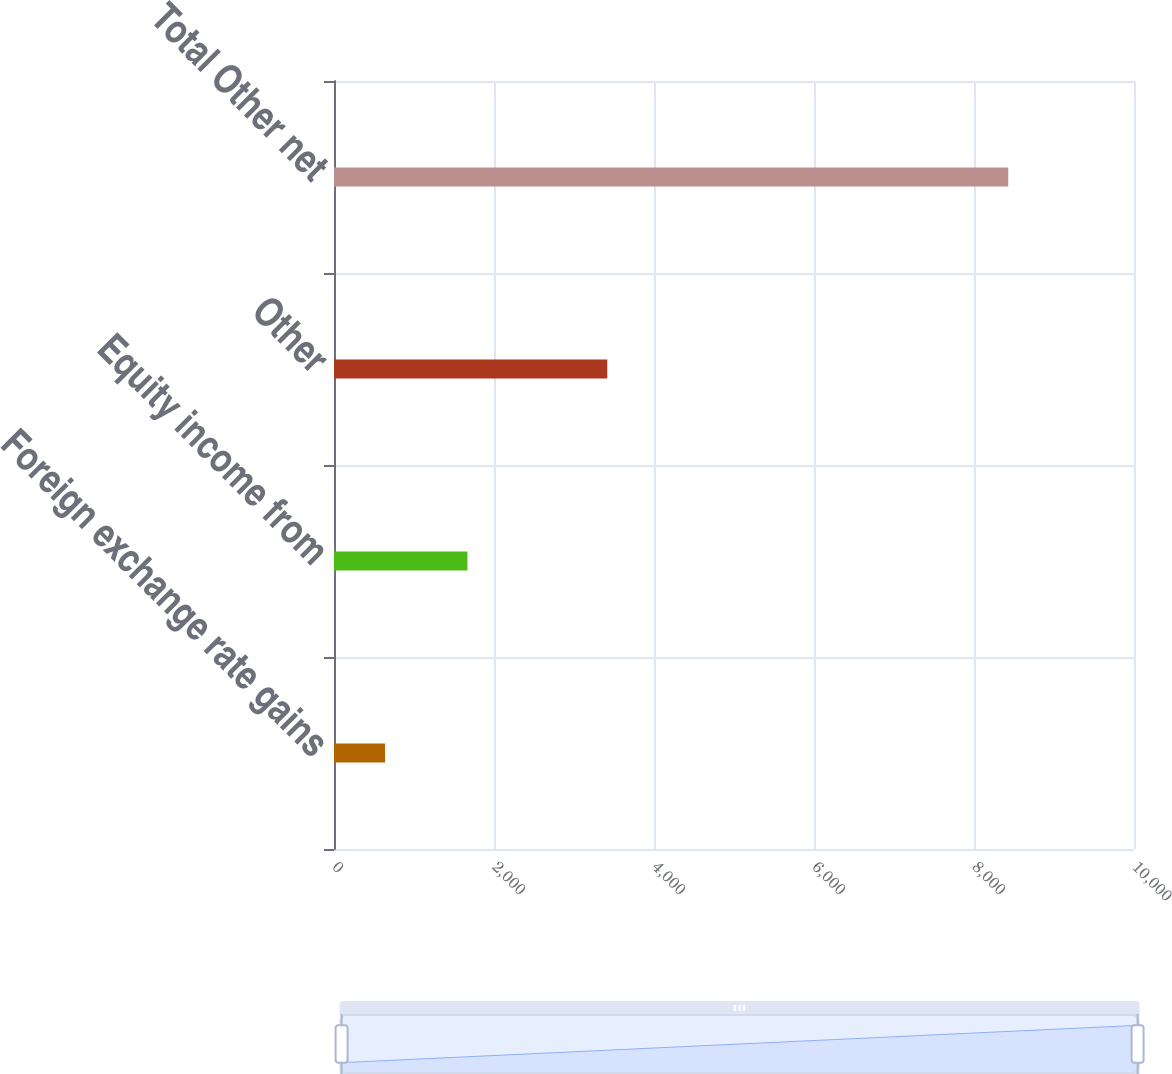<chart> <loc_0><loc_0><loc_500><loc_500><bar_chart><fcel>Foreign exchange rate gains<fcel>Equity income from<fcel>Other<fcel>Total Other net<nl><fcel>638<fcel>1668<fcel>3416<fcel>8428<nl></chart> 